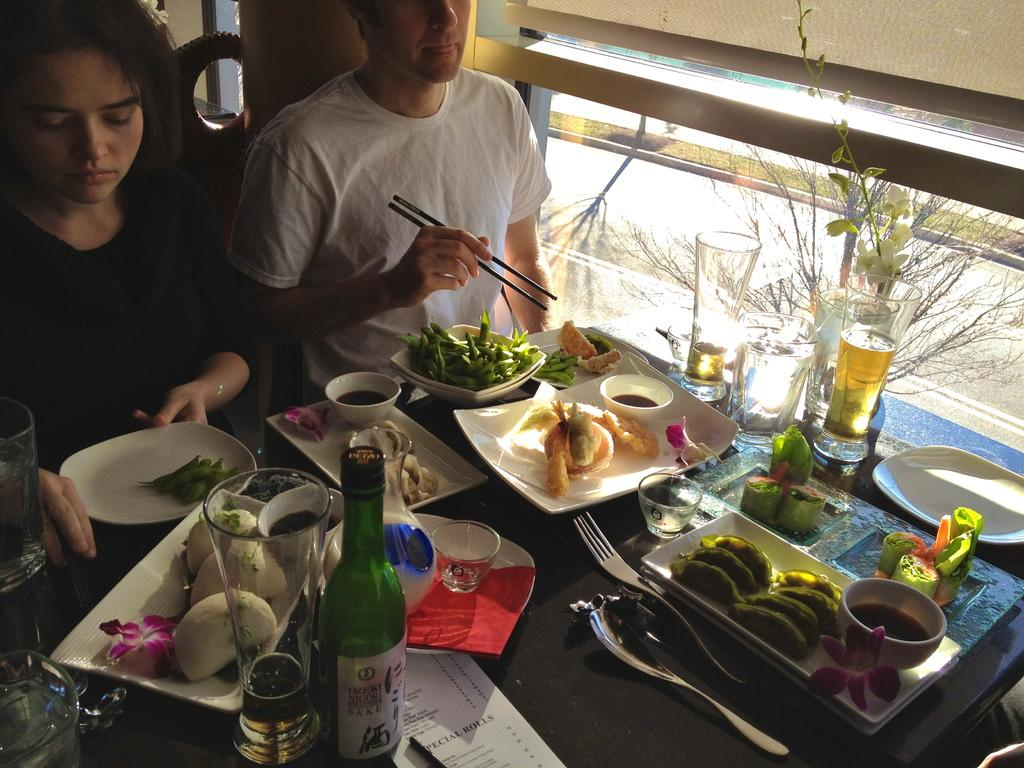What are the man and woman in the image doing? The man and woman in the image are seated on chairs. What objects can be seen in the image besides the man and woman? There is a wine bottle and food on a table in the image. What type of skin disease can be seen on the man's face in the image? There is no skin disease visible on the man's face in the image. Where is the cave located in the image? There is no cave present in the image. 